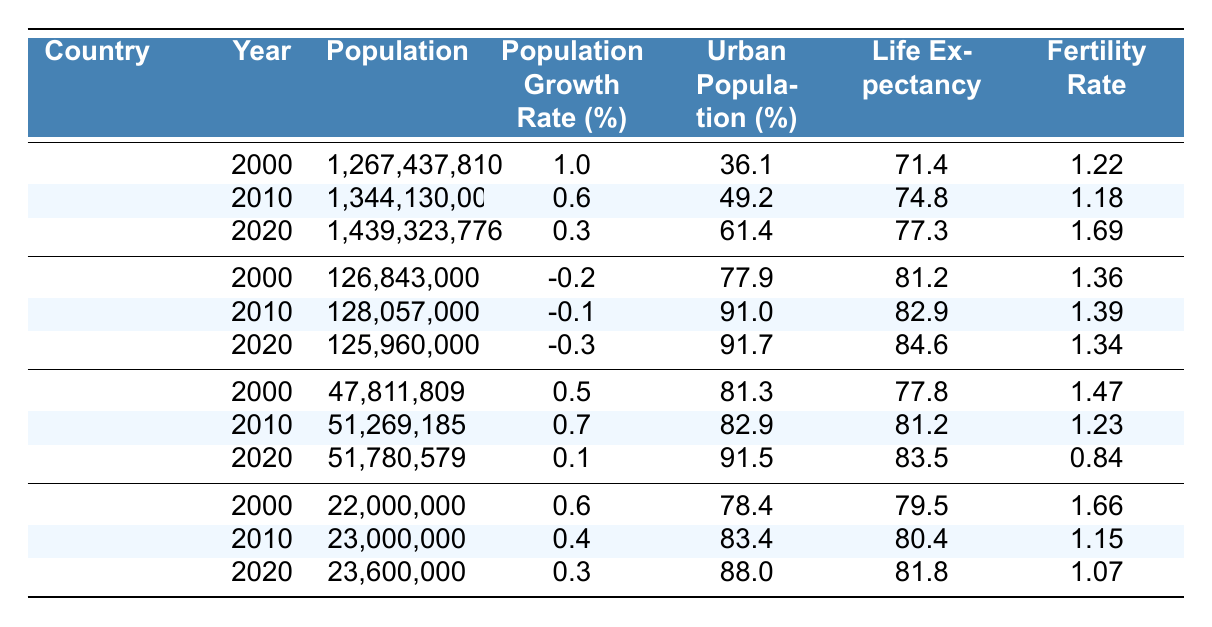What was the population of China in 2010? In the table, we can find the row for China in the year 2010, which shows the population as 1,344,130,000.
Answer: 1,344,130,000 What was the urban population percentage in Japan in 2020? Checking the row for Japan in the year 2020, the urban population percentage listed is 91.7%.
Answer: 91.7% Which country had the highest life expectancy in 2020? In the table, the life expectancy for China, Japan, South Korea, and Taiwan in 2020 are 77.3, 84.6, 83.5, and 81.8 respectively. Japan has the highest value at 84.6.
Answer: Japan What is the difference in the fertility rate of South Korea from 2000 to 2020? The fertility rate in South Korea in 2000 is 1.47, and in 2020 it is 0.84. The difference is calculated by subtracting: 1.47 - 0.84 = 0.63.
Answer: 0.63 Did Taiwan's population grow from 2010 to 2020? The population in Taiwan in 2010 was 23,000,000 and in 2020 it is 23,600,000. Since 23,600,000 is greater than 23,000,000, Taiwan's population did grow.
Answer: Yes What was the average population growth rate for South Korea from 2000 to 2020? The population growth rates for South Korea over the years are 0.5%, 0.7%, and 0.1%. Adding these together gives 0.5 + 0.7 + 0.1 = 1.3%. To find the average, we divide by 3: 1.3% / 3 = 0.4333%.
Answer: 0.43% Which country had the lowest urban population percentage in 2000? The urban population percentages for 2000 are 36.1% for China, 77.9% for Japan, 81.3% for South Korea, and 78.4% for Taiwan. The lowest percentage is 36.1%, which belongs to China.
Answer: China How much did the life expectancy in Japan increase from 2000 to 2020? The life expectancy in Japan was 81.2 in 2000 and 84.6 in 2020. The increase is calculated as 84.6 - 81.2 = 3.4 years.
Answer: 3.4 years Was the fertility rate in China higher in 2020 than in 2000? In 2000, the fertility rate in China was 1.22 and in 2020 it was 1.69. Since 1.69 is higher than 1.22, the fertility rate increased.
Answer: Yes What trend can be observed in Taiwan's urban population from 2000 to 2020? The urban population percentages for Taiwan were 78.4% in 2000, increased to 83.4% in 2010, and further increased to 88.0% in 2020, indicating a steady upward trend.
Answer: Upward trend 